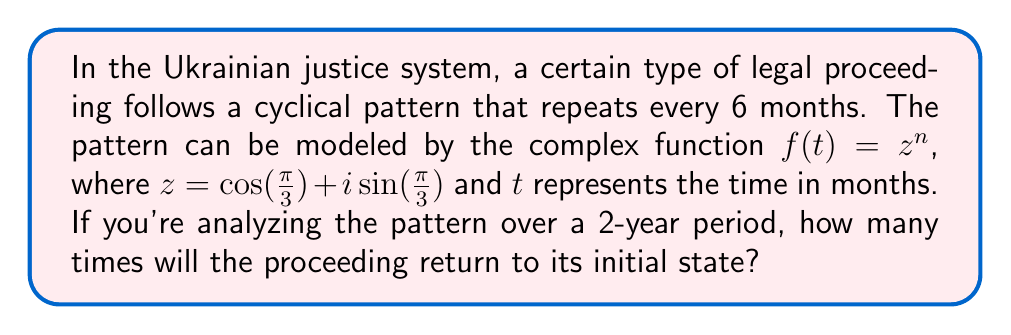Solve this math problem. Let's approach this step-by-step:

1) First, we need to understand what $z$ represents:
   $z = \cos(\frac{\pi}{3}) + i\sin(\frac{\pi}{3}) = \frac{1}{2} + i\frac{\sqrt{3}}{2}$

2) This is the complex number representation of a rotation by $\frac{\pi}{3}$ radians or 60°.

3) The function $f(t) = z^n$ represents repeated rotations by this angle.

4) We want to know how many rotations it takes to complete a full cycle (360° or $2\pi$ radians).

5) We can use De Moivre's theorem, which states:
   $(\cos\theta + i\sin\theta)^n = \cos(n\theta) + i\sin(n\theta)$

6) We want to find $n$ such that $n\cdot\frac{\pi}{3} = 2\pi$

7) Solving this equation:
   $n = \frac{2\pi}{\frac{\pi}{3}} = 6$

8) This means the cycle repeats every 6 rotations, which corresponds to 6 months.

9) In a 2-year period, which is 24 months, the number of complete cycles is:
   $\frac{24 \text{ months}}{6 \text{ months/cycle}} = 4 \text{ cycles}$

Therefore, over a 2-year period, the proceeding will return to its initial state 4 times.
Answer: 4 times 